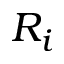<formula> <loc_0><loc_0><loc_500><loc_500>R _ { i }</formula> 